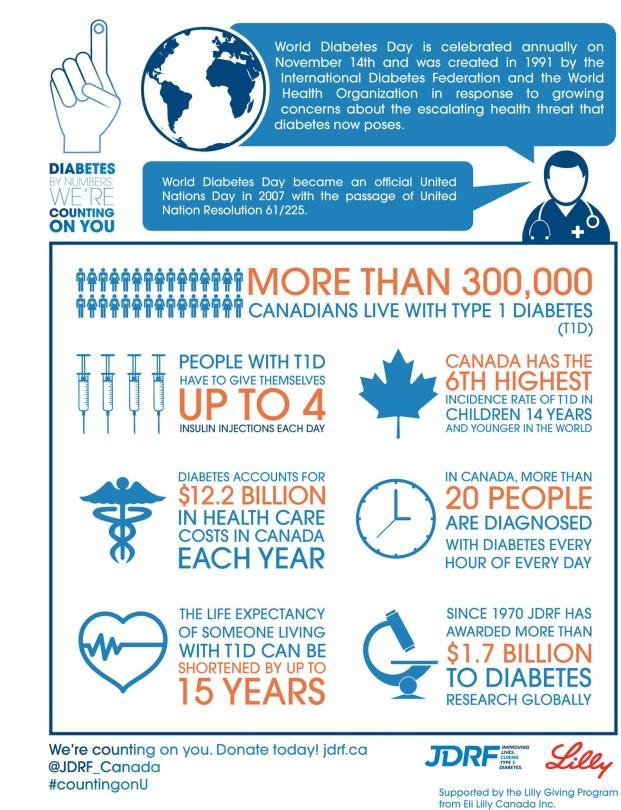Which country is sixth in number of children 14 years and younger, who have T1D?
Answer the question with a short phrase. Canada What is the average number of insulin injections taken by people with Type 1 Diabetes in a day? up to 4 